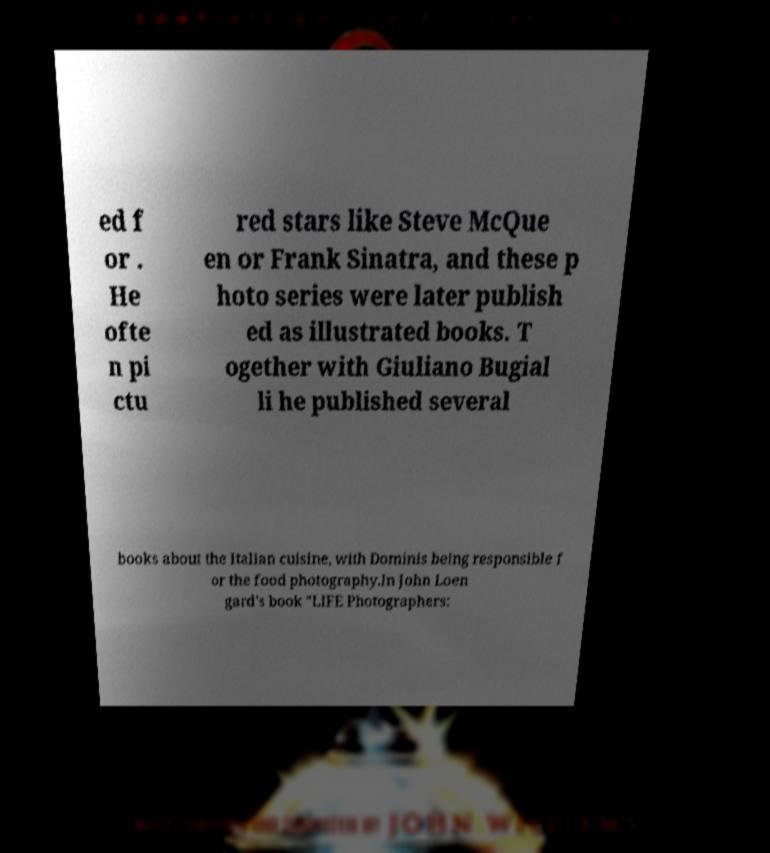Please read and relay the text visible in this image. What does it say? ed f or . He ofte n pi ctu red stars like Steve McQue en or Frank Sinatra, and these p hoto series were later publish ed as illustrated books. T ogether with Giuliano Bugial li he published several books about the Italian cuisine, with Dominis being responsible f or the food photography.In John Loen gard's book "LIFE Photographers: 